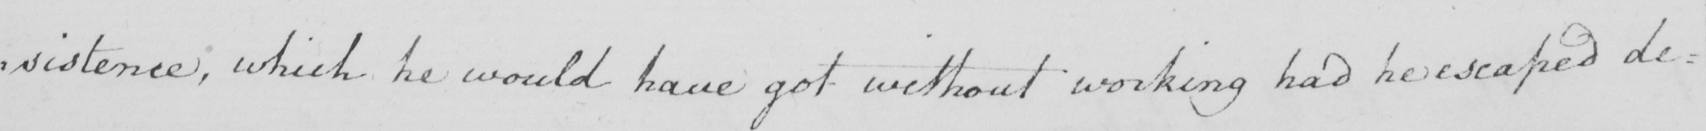Please provide the text content of this handwritten line. : sistence , which he would have got without working had he escaped de= 